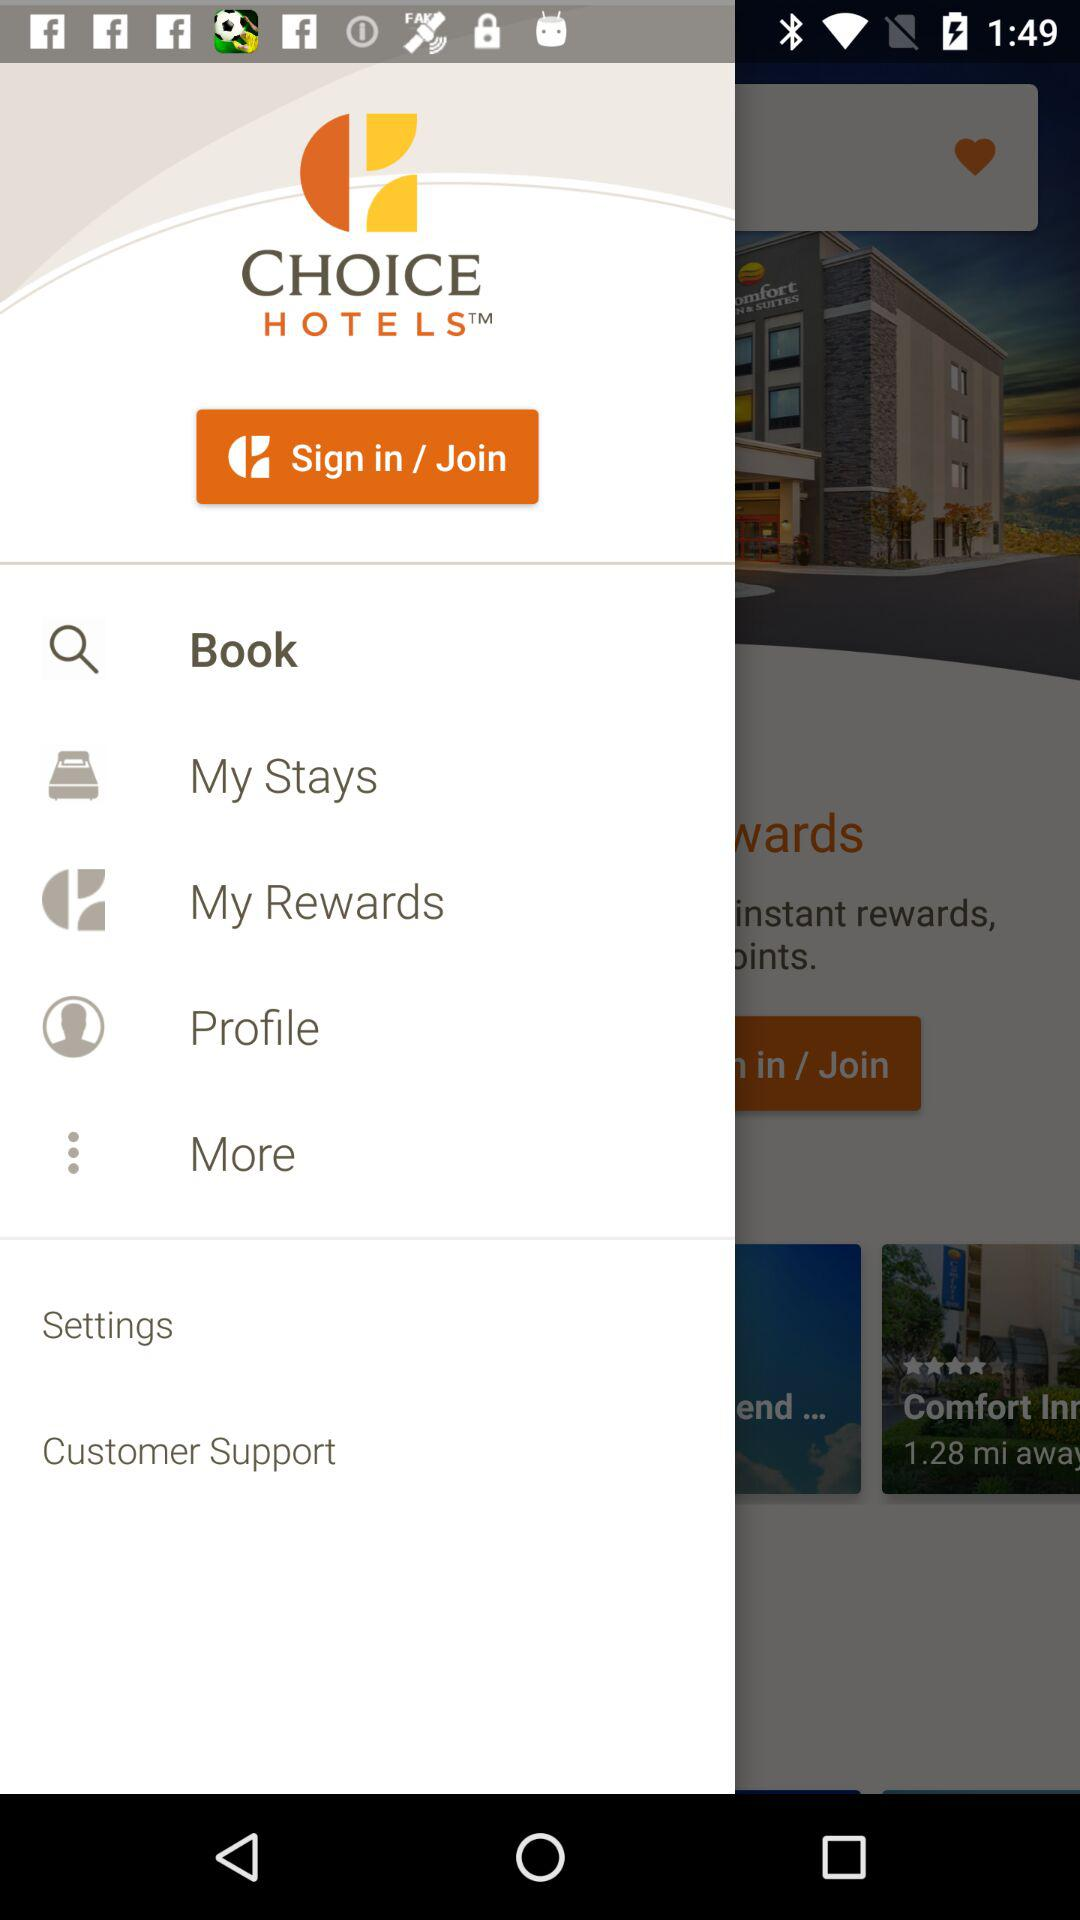What is the name of the application? The name of the application is "Choice Hotels". 